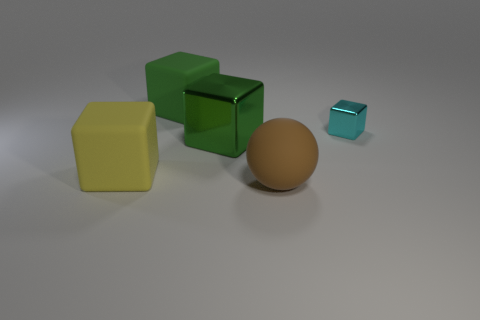What number of objects are either large cubes or big matte objects? 4 